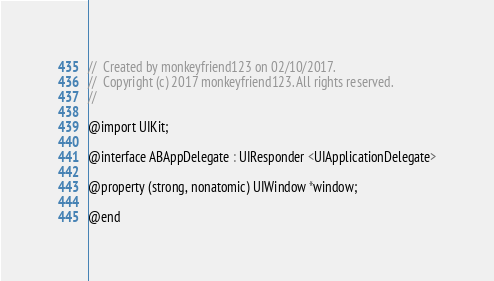<code> <loc_0><loc_0><loc_500><loc_500><_C_>//  Created by monkeyfriend123 on 02/10/2017.
//  Copyright (c) 2017 monkeyfriend123. All rights reserved.
//

@import UIKit;

@interface ABAppDelegate : UIResponder <UIApplicationDelegate>

@property (strong, nonatomic) UIWindow *window;

@end
</code> 